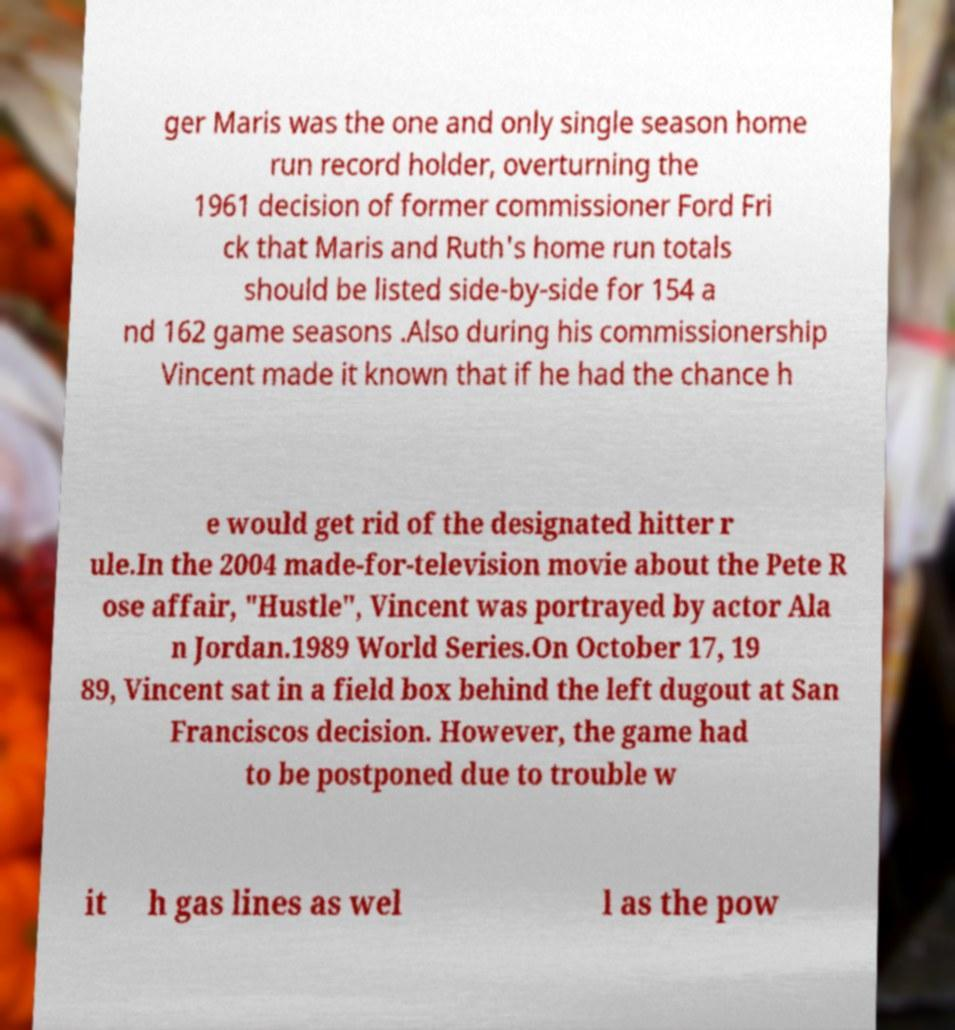Could you assist in decoding the text presented in this image and type it out clearly? ger Maris was the one and only single season home run record holder, overturning the 1961 decision of former commissioner Ford Fri ck that Maris and Ruth's home run totals should be listed side-by-side for 154 a nd 162 game seasons .Also during his commissionership Vincent made it known that if he had the chance h e would get rid of the designated hitter r ule.In the 2004 made-for-television movie about the Pete R ose affair, "Hustle", Vincent was portrayed by actor Ala n Jordan.1989 World Series.On October 17, 19 89, Vincent sat in a field box behind the left dugout at San Franciscos decision. However, the game had to be postponed due to trouble w it h gas lines as wel l as the pow 